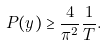<formula> <loc_0><loc_0><loc_500><loc_500>P ( y ) \geq \frac { 4 } { \pi ^ { 2 } } \frac { 1 } { T } .</formula> 